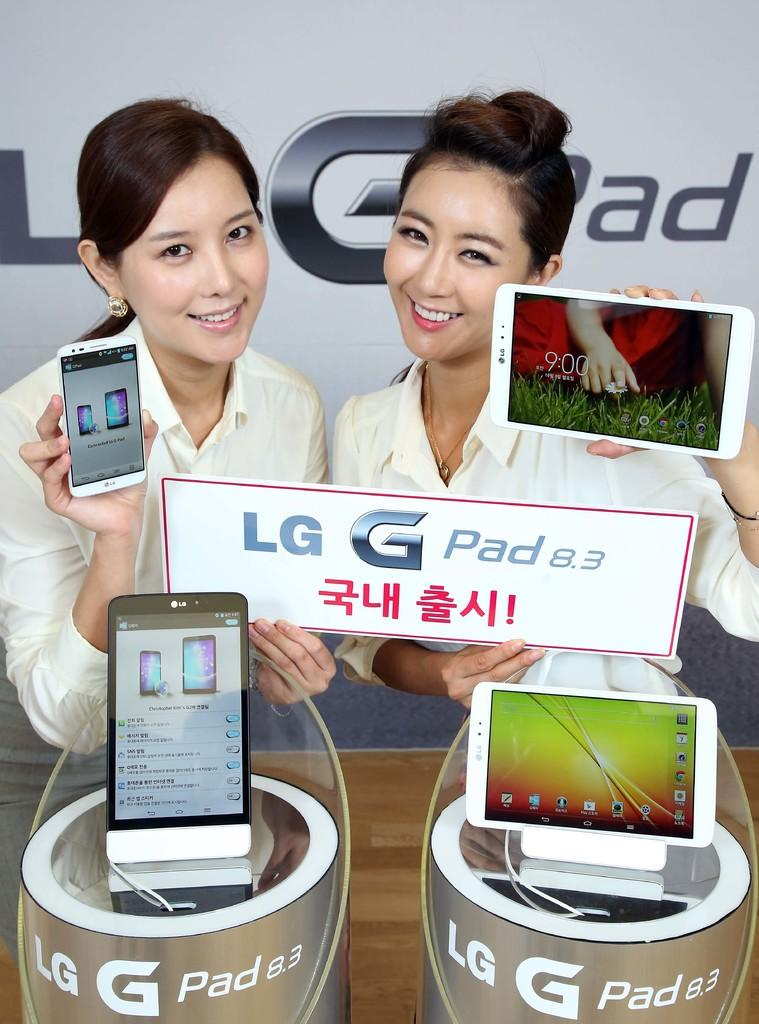<image>
Provide a brief description of the given image. Two women stand in front of an LG Pad 8.3 display holding products in their hands. 